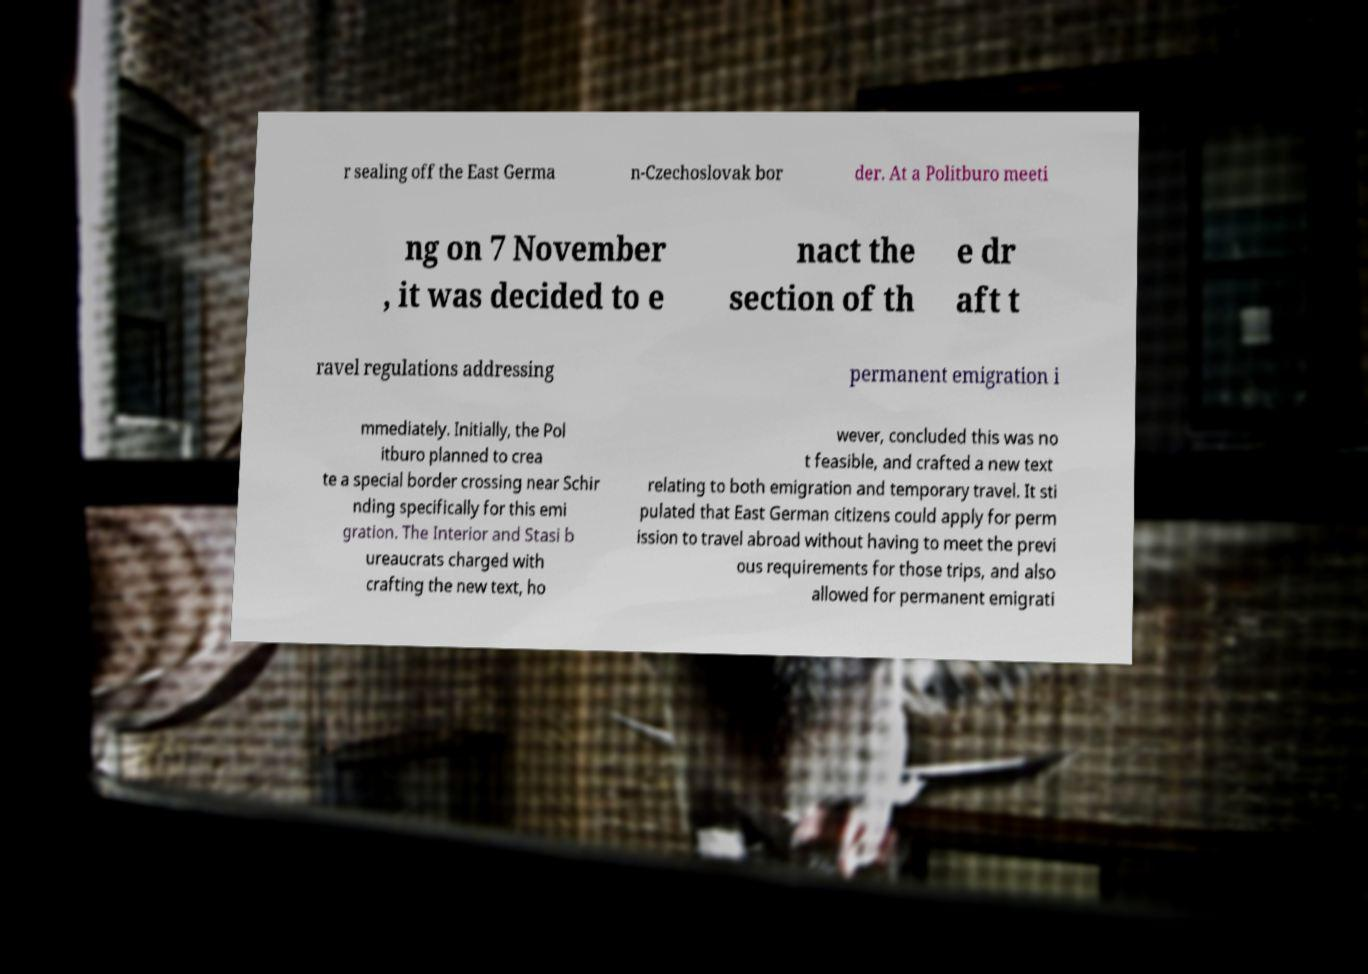There's text embedded in this image that I need extracted. Can you transcribe it verbatim? r sealing off the East Germa n-Czechoslovak bor der. At a Politburo meeti ng on 7 November , it was decided to e nact the section of th e dr aft t ravel regulations addressing permanent emigration i mmediately. Initially, the Pol itburo planned to crea te a special border crossing near Schir nding specifically for this emi gration. The Interior and Stasi b ureaucrats charged with crafting the new text, ho wever, concluded this was no t feasible, and crafted a new text relating to both emigration and temporary travel. It sti pulated that East German citizens could apply for perm ission to travel abroad without having to meet the previ ous requirements for those trips, and also allowed for permanent emigrati 